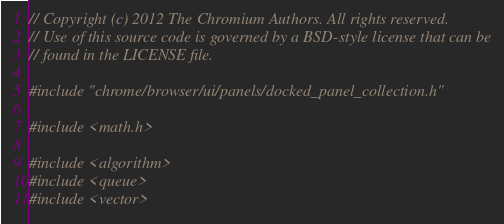<code> <loc_0><loc_0><loc_500><loc_500><_C++_>// Copyright (c) 2012 The Chromium Authors. All rights reserved.
// Use of this source code is governed by a BSD-style license that can be
// found in the LICENSE file.

#include "chrome/browser/ui/panels/docked_panel_collection.h"

#include <math.h>

#include <algorithm>
#include <queue>
#include <vector>
</code> 